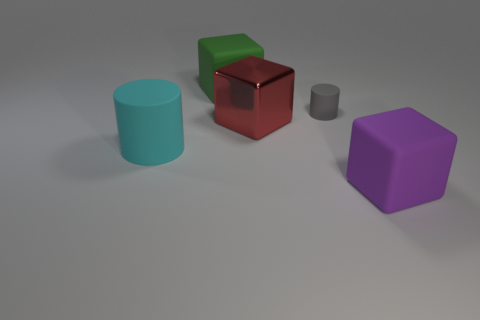What is the tiny gray thing that is right of the large green block made of?
Your answer should be very brief. Rubber. What number of green things are either metal cubes or large rubber blocks?
Provide a succinct answer. 1. Is there any other thing that is the same material as the big red object?
Your answer should be compact. No. Are the big object behind the big red shiny block and the large red thing made of the same material?
Your response must be concise. No. How many objects are large green matte objects or matte things to the left of the purple rubber block?
Ensure brevity in your answer.  3. What number of purple matte things are behind the big object that is on the left side of the green rubber object that is behind the large cylinder?
Offer a terse response. 0. There is a large rubber thing behind the cyan object; does it have the same shape as the large cyan rubber thing?
Your answer should be compact. No. There is a matte block in front of the red thing; is there a matte object that is behind it?
Keep it short and to the point. Yes. What number of big gray metal cylinders are there?
Offer a very short reply. 0. There is a block that is left of the tiny matte thing and in front of the green matte object; what is its color?
Keep it short and to the point. Red. 